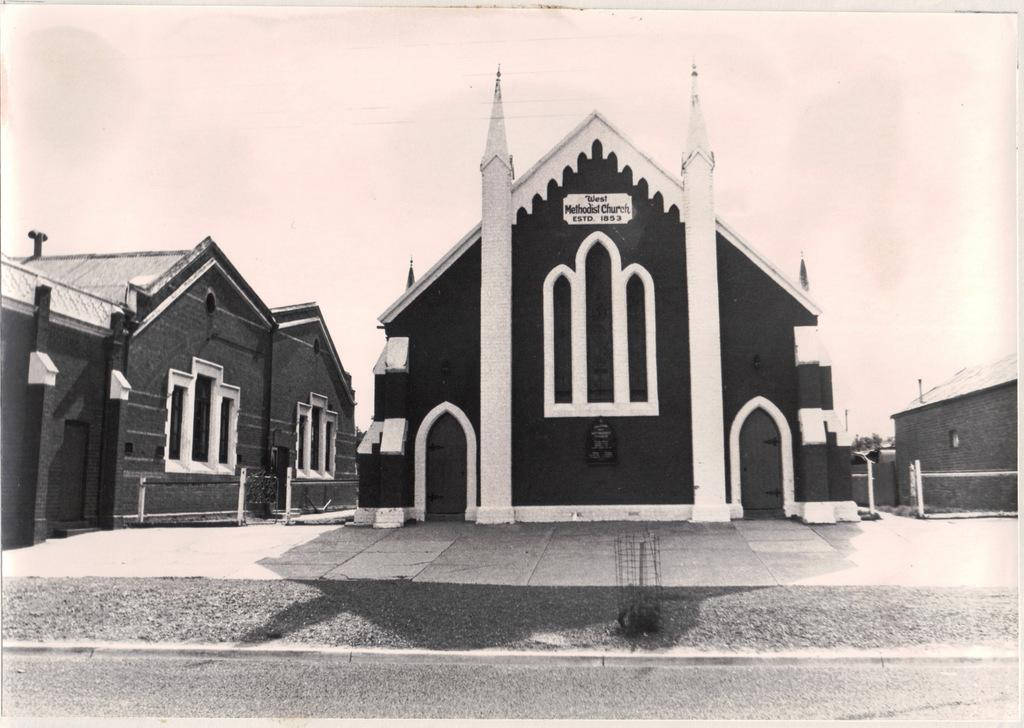What is the main feature of the image? There is a road in the image. What else can be seen in the center of the image? There are buildings in the center of the image. What type of barrier is present in the image? There is a metal fence in the image. What can be seen in the background of the image? The sky is visible in the background of the image. How many trees are visible in the image? There are no trees visible in the image. What type of print can be seen on the buildings in the image? There is no print visible on the buildings in the image. 